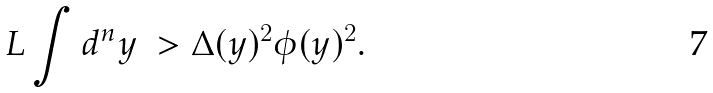Convert formula to latex. <formula><loc_0><loc_0><loc_500><loc_500>L \int d ^ { n } y \ > \Delta ( y ) ^ { 2 } \phi ( y ) ^ { 2 } .</formula> 